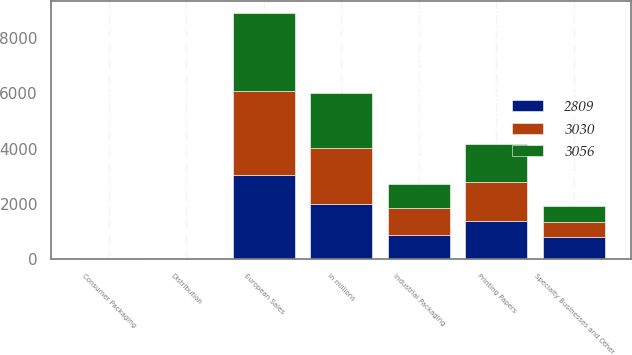<chart> <loc_0><loc_0><loc_500><loc_500><stacked_bar_chart><ecel><fcel>In millions<fcel>Printing Papers<fcel>Industrial Packaging<fcel>Consumer Packaging<fcel>Distribution<fcel>Specialty Businesses and Other<fcel>European Sales<nl><fcel>3030<fcel>2006<fcel>1440<fcel>1001<fcel>18<fcel>1<fcel>570<fcel>3030<nl><fcel>3056<fcel>2005<fcel>1364<fcel>851<fcel>21<fcel>1<fcel>572<fcel>2809<nl><fcel>2809<fcel>2004<fcel>1370<fcel>869<fcel>22<fcel>2<fcel>793<fcel>3056<nl></chart> 